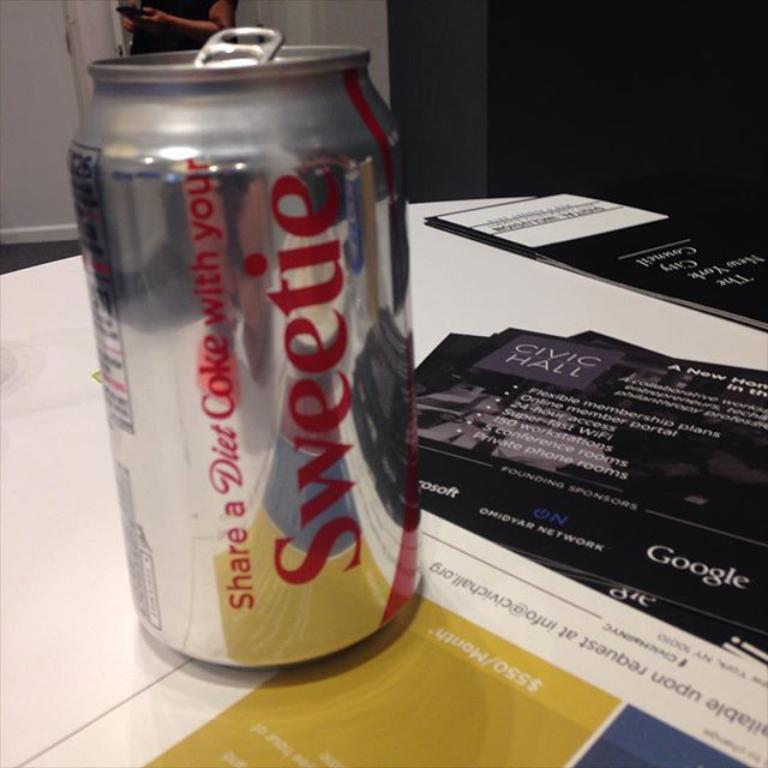<image>
Describe the image concisely. the word sweetie that is on a coca cola can 